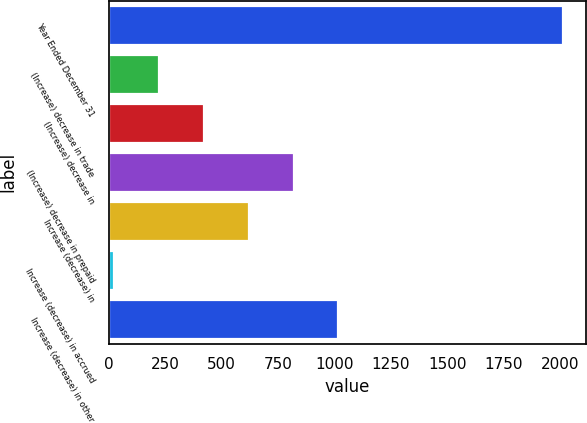Convert chart to OTSL. <chart><loc_0><loc_0><loc_500><loc_500><bar_chart><fcel>Year Ended December 31<fcel>(Increase) decrease in trade<fcel>(Increase) decrease in<fcel>(Increase) decrease in prepaid<fcel>Increase (decrease) in<fcel>Increase (decrease) in accrued<fcel>Increase (decrease) in other<nl><fcel>2013<fcel>221.1<fcel>420.2<fcel>818.4<fcel>619.3<fcel>22<fcel>1017.5<nl></chart> 